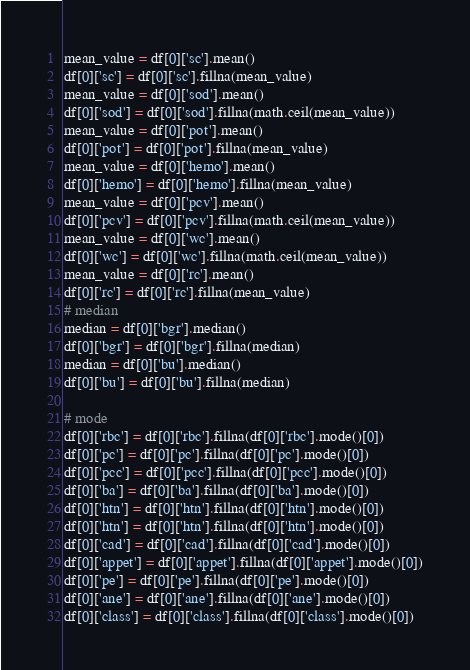Convert code to text. <code><loc_0><loc_0><loc_500><loc_500><_Python_>mean_value = df[0]['sc'].mean()
df[0]['sc'] = df[0]['sc'].fillna(mean_value)
mean_value = df[0]['sod'].mean()
df[0]['sod'] = df[0]['sod'].fillna(math.ceil(mean_value))
mean_value = df[0]['pot'].mean()
df[0]['pot'] = df[0]['pot'].fillna(mean_value)
mean_value = df[0]['hemo'].mean()
df[0]['hemo'] = df[0]['hemo'].fillna(mean_value)
mean_value = df[0]['pcv'].mean()
df[0]['pcv'] = df[0]['pcv'].fillna(math.ceil(mean_value))
mean_value = df[0]['wc'].mean()
df[0]['wc'] = df[0]['wc'].fillna(math.ceil(mean_value))
mean_value = df[0]['rc'].mean()
df[0]['rc'] = df[0]['rc'].fillna(mean_value)
# median
median = df[0]['bgr'].median()
df[0]['bgr'] = df[0]['bgr'].fillna(median)
median = df[0]['bu'].median()
df[0]['bu'] = df[0]['bu'].fillna(median)

# mode
df[0]['rbc'] = df[0]['rbc'].fillna(df[0]['rbc'].mode()[0])
df[0]['pc'] = df[0]['pc'].fillna(df[0]['pc'].mode()[0])
df[0]['pcc'] = df[0]['pcc'].fillna(df[0]['pcc'].mode()[0])
df[0]['ba'] = df[0]['ba'].fillna(df[0]['ba'].mode()[0])
df[0]['htn'] = df[0]['htn'].fillna(df[0]['htn'].mode()[0])
df[0]['htn'] = df[0]['htn'].fillna(df[0]['htn'].mode()[0])
df[0]['cad'] = df[0]['cad'].fillna(df[0]['cad'].mode()[0])
df[0]['appet'] = df[0]['appet'].fillna(df[0]['appet'].mode()[0])
df[0]['pe'] = df[0]['pe'].fillna(df[0]['pe'].mode()[0])
df[0]['ane'] = df[0]['ane'].fillna(df[0]['ane'].mode()[0])
df[0]['class'] = df[0]['class'].fillna(df[0]['class'].mode()[0])
</code> 